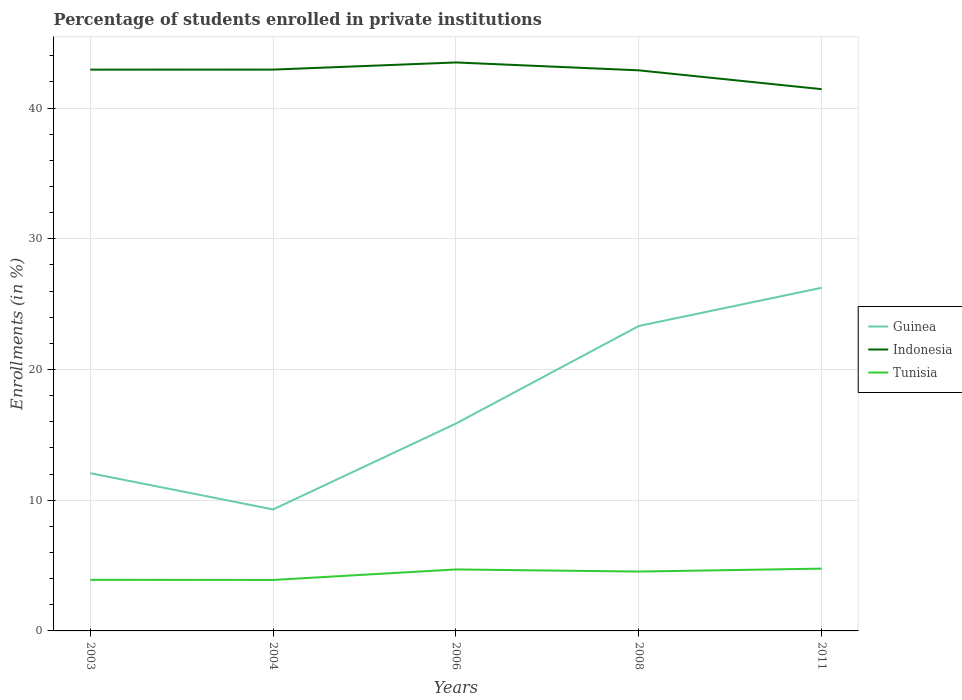Is the number of lines equal to the number of legend labels?
Offer a very short reply. Yes. Across all years, what is the maximum percentage of trained teachers in Guinea?
Offer a very short reply. 9.29. In which year was the percentage of trained teachers in Indonesia maximum?
Keep it short and to the point. 2011. What is the total percentage of trained teachers in Tunisia in the graph?
Ensure brevity in your answer.  -0.79. What is the difference between the highest and the second highest percentage of trained teachers in Indonesia?
Offer a very short reply. 2.04. How many years are there in the graph?
Your answer should be compact. 5. What is the title of the graph?
Offer a very short reply. Percentage of students enrolled in private institutions. Does "Equatorial Guinea" appear as one of the legend labels in the graph?
Give a very brief answer. No. What is the label or title of the X-axis?
Keep it short and to the point. Years. What is the label or title of the Y-axis?
Give a very brief answer. Enrollments (in %). What is the Enrollments (in %) in Guinea in 2003?
Give a very brief answer. 12.07. What is the Enrollments (in %) in Indonesia in 2003?
Your answer should be very brief. 42.94. What is the Enrollments (in %) in Tunisia in 2003?
Offer a terse response. 3.91. What is the Enrollments (in %) of Guinea in 2004?
Give a very brief answer. 9.29. What is the Enrollments (in %) in Indonesia in 2004?
Provide a short and direct response. 42.94. What is the Enrollments (in %) in Tunisia in 2004?
Provide a succinct answer. 3.9. What is the Enrollments (in %) in Guinea in 2006?
Provide a short and direct response. 15.86. What is the Enrollments (in %) of Indonesia in 2006?
Your answer should be very brief. 43.49. What is the Enrollments (in %) of Tunisia in 2006?
Offer a terse response. 4.7. What is the Enrollments (in %) in Guinea in 2008?
Your response must be concise. 23.33. What is the Enrollments (in %) of Indonesia in 2008?
Ensure brevity in your answer.  42.89. What is the Enrollments (in %) in Tunisia in 2008?
Ensure brevity in your answer.  4.54. What is the Enrollments (in %) in Guinea in 2011?
Keep it short and to the point. 26.25. What is the Enrollments (in %) of Indonesia in 2011?
Offer a terse response. 41.45. What is the Enrollments (in %) in Tunisia in 2011?
Provide a succinct answer. 4.77. Across all years, what is the maximum Enrollments (in %) in Guinea?
Your answer should be very brief. 26.25. Across all years, what is the maximum Enrollments (in %) in Indonesia?
Ensure brevity in your answer.  43.49. Across all years, what is the maximum Enrollments (in %) in Tunisia?
Your response must be concise. 4.77. Across all years, what is the minimum Enrollments (in %) in Guinea?
Offer a very short reply. 9.29. Across all years, what is the minimum Enrollments (in %) of Indonesia?
Offer a terse response. 41.45. Across all years, what is the minimum Enrollments (in %) in Tunisia?
Provide a succinct answer. 3.9. What is the total Enrollments (in %) of Guinea in the graph?
Give a very brief answer. 86.8. What is the total Enrollments (in %) of Indonesia in the graph?
Ensure brevity in your answer.  213.7. What is the total Enrollments (in %) in Tunisia in the graph?
Provide a succinct answer. 21.82. What is the difference between the Enrollments (in %) in Guinea in 2003 and that in 2004?
Offer a very short reply. 2.77. What is the difference between the Enrollments (in %) in Indonesia in 2003 and that in 2004?
Offer a very short reply. -0. What is the difference between the Enrollments (in %) in Tunisia in 2003 and that in 2004?
Give a very brief answer. 0.01. What is the difference between the Enrollments (in %) of Guinea in 2003 and that in 2006?
Provide a short and direct response. -3.8. What is the difference between the Enrollments (in %) of Indonesia in 2003 and that in 2006?
Ensure brevity in your answer.  -0.55. What is the difference between the Enrollments (in %) of Tunisia in 2003 and that in 2006?
Ensure brevity in your answer.  -0.79. What is the difference between the Enrollments (in %) in Guinea in 2003 and that in 2008?
Your answer should be compact. -11.26. What is the difference between the Enrollments (in %) in Indonesia in 2003 and that in 2008?
Your response must be concise. 0.05. What is the difference between the Enrollments (in %) in Tunisia in 2003 and that in 2008?
Your answer should be compact. -0.63. What is the difference between the Enrollments (in %) in Guinea in 2003 and that in 2011?
Ensure brevity in your answer.  -14.18. What is the difference between the Enrollments (in %) in Indonesia in 2003 and that in 2011?
Give a very brief answer. 1.49. What is the difference between the Enrollments (in %) of Tunisia in 2003 and that in 2011?
Your answer should be compact. -0.86. What is the difference between the Enrollments (in %) of Guinea in 2004 and that in 2006?
Offer a terse response. -6.57. What is the difference between the Enrollments (in %) in Indonesia in 2004 and that in 2006?
Offer a very short reply. -0.55. What is the difference between the Enrollments (in %) of Tunisia in 2004 and that in 2006?
Ensure brevity in your answer.  -0.81. What is the difference between the Enrollments (in %) of Guinea in 2004 and that in 2008?
Provide a succinct answer. -14.03. What is the difference between the Enrollments (in %) of Indonesia in 2004 and that in 2008?
Make the answer very short. 0.06. What is the difference between the Enrollments (in %) in Tunisia in 2004 and that in 2008?
Make the answer very short. -0.64. What is the difference between the Enrollments (in %) in Guinea in 2004 and that in 2011?
Offer a terse response. -16.96. What is the difference between the Enrollments (in %) of Indonesia in 2004 and that in 2011?
Your answer should be very brief. 1.5. What is the difference between the Enrollments (in %) in Tunisia in 2004 and that in 2011?
Your answer should be very brief. -0.87. What is the difference between the Enrollments (in %) of Guinea in 2006 and that in 2008?
Provide a succinct answer. -7.46. What is the difference between the Enrollments (in %) in Indonesia in 2006 and that in 2008?
Ensure brevity in your answer.  0.6. What is the difference between the Enrollments (in %) of Tunisia in 2006 and that in 2008?
Offer a terse response. 0.16. What is the difference between the Enrollments (in %) of Guinea in 2006 and that in 2011?
Ensure brevity in your answer.  -10.39. What is the difference between the Enrollments (in %) in Indonesia in 2006 and that in 2011?
Keep it short and to the point. 2.04. What is the difference between the Enrollments (in %) of Tunisia in 2006 and that in 2011?
Give a very brief answer. -0.06. What is the difference between the Enrollments (in %) in Guinea in 2008 and that in 2011?
Offer a terse response. -2.92. What is the difference between the Enrollments (in %) in Indonesia in 2008 and that in 2011?
Provide a succinct answer. 1.44. What is the difference between the Enrollments (in %) of Tunisia in 2008 and that in 2011?
Provide a short and direct response. -0.23. What is the difference between the Enrollments (in %) in Guinea in 2003 and the Enrollments (in %) in Indonesia in 2004?
Ensure brevity in your answer.  -30.88. What is the difference between the Enrollments (in %) of Guinea in 2003 and the Enrollments (in %) of Tunisia in 2004?
Offer a very short reply. 8.17. What is the difference between the Enrollments (in %) of Indonesia in 2003 and the Enrollments (in %) of Tunisia in 2004?
Give a very brief answer. 39.04. What is the difference between the Enrollments (in %) of Guinea in 2003 and the Enrollments (in %) of Indonesia in 2006?
Provide a short and direct response. -31.42. What is the difference between the Enrollments (in %) in Guinea in 2003 and the Enrollments (in %) in Tunisia in 2006?
Offer a very short reply. 7.36. What is the difference between the Enrollments (in %) of Indonesia in 2003 and the Enrollments (in %) of Tunisia in 2006?
Provide a short and direct response. 38.23. What is the difference between the Enrollments (in %) in Guinea in 2003 and the Enrollments (in %) in Indonesia in 2008?
Keep it short and to the point. -30.82. What is the difference between the Enrollments (in %) in Guinea in 2003 and the Enrollments (in %) in Tunisia in 2008?
Your answer should be compact. 7.53. What is the difference between the Enrollments (in %) in Indonesia in 2003 and the Enrollments (in %) in Tunisia in 2008?
Offer a very short reply. 38.4. What is the difference between the Enrollments (in %) of Guinea in 2003 and the Enrollments (in %) of Indonesia in 2011?
Offer a very short reply. -29.38. What is the difference between the Enrollments (in %) in Guinea in 2003 and the Enrollments (in %) in Tunisia in 2011?
Your response must be concise. 7.3. What is the difference between the Enrollments (in %) of Indonesia in 2003 and the Enrollments (in %) of Tunisia in 2011?
Provide a short and direct response. 38.17. What is the difference between the Enrollments (in %) in Guinea in 2004 and the Enrollments (in %) in Indonesia in 2006?
Ensure brevity in your answer.  -34.2. What is the difference between the Enrollments (in %) of Guinea in 2004 and the Enrollments (in %) of Tunisia in 2006?
Provide a succinct answer. 4.59. What is the difference between the Enrollments (in %) of Indonesia in 2004 and the Enrollments (in %) of Tunisia in 2006?
Keep it short and to the point. 38.24. What is the difference between the Enrollments (in %) of Guinea in 2004 and the Enrollments (in %) of Indonesia in 2008?
Offer a very short reply. -33.59. What is the difference between the Enrollments (in %) in Guinea in 2004 and the Enrollments (in %) in Tunisia in 2008?
Keep it short and to the point. 4.75. What is the difference between the Enrollments (in %) in Indonesia in 2004 and the Enrollments (in %) in Tunisia in 2008?
Your answer should be compact. 38.4. What is the difference between the Enrollments (in %) in Guinea in 2004 and the Enrollments (in %) in Indonesia in 2011?
Your answer should be very brief. -32.15. What is the difference between the Enrollments (in %) of Guinea in 2004 and the Enrollments (in %) of Tunisia in 2011?
Your answer should be compact. 4.53. What is the difference between the Enrollments (in %) of Indonesia in 2004 and the Enrollments (in %) of Tunisia in 2011?
Offer a terse response. 38.18. What is the difference between the Enrollments (in %) of Guinea in 2006 and the Enrollments (in %) of Indonesia in 2008?
Give a very brief answer. -27.02. What is the difference between the Enrollments (in %) in Guinea in 2006 and the Enrollments (in %) in Tunisia in 2008?
Offer a terse response. 11.32. What is the difference between the Enrollments (in %) in Indonesia in 2006 and the Enrollments (in %) in Tunisia in 2008?
Your response must be concise. 38.95. What is the difference between the Enrollments (in %) of Guinea in 2006 and the Enrollments (in %) of Indonesia in 2011?
Give a very brief answer. -25.58. What is the difference between the Enrollments (in %) of Guinea in 2006 and the Enrollments (in %) of Tunisia in 2011?
Give a very brief answer. 11.1. What is the difference between the Enrollments (in %) of Indonesia in 2006 and the Enrollments (in %) of Tunisia in 2011?
Offer a very short reply. 38.72. What is the difference between the Enrollments (in %) in Guinea in 2008 and the Enrollments (in %) in Indonesia in 2011?
Make the answer very short. -18.12. What is the difference between the Enrollments (in %) in Guinea in 2008 and the Enrollments (in %) in Tunisia in 2011?
Provide a succinct answer. 18.56. What is the difference between the Enrollments (in %) of Indonesia in 2008 and the Enrollments (in %) of Tunisia in 2011?
Provide a succinct answer. 38.12. What is the average Enrollments (in %) of Guinea per year?
Your answer should be compact. 17.36. What is the average Enrollments (in %) in Indonesia per year?
Make the answer very short. 42.74. What is the average Enrollments (in %) of Tunisia per year?
Give a very brief answer. 4.36. In the year 2003, what is the difference between the Enrollments (in %) in Guinea and Enrollments (in %) in Indonesia?
Make the answer very short. -30.87. In the year 2003, what is the difference between the Enrollments (in %) of Guinea and Enrollments (in %) of Tunisia?
Provide a short and direct response. 8.16. In the year 2003, what is the difference between the Enrollments (in %) in Indonesia and Enrollments (in %) in Tunisia?
Provide a succinct answer. 39.03. In the year 2004, what is the difference between the Enrollments (in %) in Guinea and Enrollments (in %) in Indonesia?
Your answer should be compact. -33.65. In the year 2004, what is the difference between the Enrollments (in %) in Guinea and Enrollments (in %) in Tunisia?
Your answer should be very brief. 5.39. In the year 2004, what is the difference between the Enrollments (in %) of Indonesia and Enrollments (in %) of Tunisia?
Make the answer very short. 39.04. In the year 2006, what is the difference between the Enrollments (in %) of Guinea and Enrollments (in %) of Indonesia?
Your answer should be compact. -27.62. In the year 2006, what is the difference between the Enrollments (in %) of Guinea and Enrollments (in %) of Tunisia?
Your response must be concise. 11.16. In the year 2006, what is the difference between the Enrollments (in %) of Indonesia and Enrollments (in %) of Tunisia?
Your response must be concise. 38.78. In the year 2008, what is the difference between the Enrollments (in %) of Guinea and Enrollments (in %) of Indonesia?
Your response must be concise. -19.56. In the year 2008, what is the difference between the Enrollments (in %) in Guinea and Enrollments (in %) in Tunisia?
Your answer should be compact. 18.79. In the year 2008, what is the difference between the Enrollments (in %) in Indonesia and Enrollments (in %) in Tunisia?
Offer a terse response. 38.34. In the year 2011, what is the difference between the Enrollments (in %) in Guinea and Enrollments (in %) in Indonesia?
Offer a terse response. -15.19. In the year 2011, what is the difference between the Enrollments (in %) in Guinea and Enrollments (in %) in Tunisia?
Provide a succinct answer. 21.48. In the year 2011, what is the difference between the Enrollments (in %) in Indonesia and Enrollments (in %) in Tunisia?
Offer a very short reply. 36.68. What is the ratio of the Enrollments (in %) of Guinea in 2003 to that in 2004?
Ensure brevity in your answer.  1.3. What is the ratio of the Enrollments (in %) in Guinea in 2003 to that in 2006?
Make the answer very short. 0.76. What is the ratio of the Enrollments (in %) in Indonesia in 2003 to that in 2006?
Your answer should be compact. 0.99. What is the ratio of the Enrollments (in %) in Tunisia in 2003 to that in 2006?
Make the answer very short. 0.83. What is the ratio of the Enrollments (in %) of Guinea in 2003 to that in 2008?
Your answer should be very brief. 0.52. What is the ratio of the Enrollments (in %) of Tunisia in 2003 to that in 2008?
Make the answer very short. 0.86. What is the ratio of the Enrollments (in %) of Guinea in 2003 to that in 2011?
Your response must be concise. 0.46. What is the ratio of the Enrollments (in %) in Indonesia in 2003 to that in 2011?
Offer a very short reply. 1.04. What is the ratio of the Enrollments (in %) in Tunisia in 2003 to that in 2011?
Make the answer very short. 0.82. What is the ratio of the Enrollments (in %) of Guinea in 2004 to that in 2006?
Make the answer very short. 0.59. What is the ratio of the Enrollments (in %) in Indonesia in 2004 to that in 2006?
Your response must be concise. 0.99. What is the ratio of the Enrollments (in %) in Tunisia in 2004 to that in 2006?
Your answer should be very brief. 0.83. What is the ratio of the Enrollments (in %) in Guinea in 2004 to that in 2008?
Make the answer very short. 0.4. What is the ratio of the Enrollments (in %) in Indonesia in 2004 to that in 2008?
Make the answer very short. 1. What is the ratio of the Enrollments (in %) of Tunisia in 2004 to that in 2008?
Your response must be concise. 0.86. What is the ratio of the Enrollments (in %) in Guinea in 2004 to that in 2011?
Give a very brief answer. 0.35. What is the ratio of the Enrollments (in %) in Indonesia in 2004 to that in 2011?
Ensure brevity in your answer.  1.04. What is the ratio of the Enrollments (in %) in Tunisia in 2004 to that in 2011?
Provide a succinct answer. 0.82. What is the ratio of the Enrollments (in %) of Guinea in 2006 to that in 2008?
Offer a terse response. 0.68. What is the ratio of the Enrollments (in %) of Indonesia in 2006 to that in 2008?
Your response must be concise. 1.01. What is the ratio of the Enrollments (in %) in Tunisia in 2006 to that in 2008?
Ensure brevity in your answer.  1.04. What is the ratio of the Enrollments (in %) of Guinea in 2006 to that in 2011?
Give a very brief answer. 0.6. What is the ratio of the Enrollments (in %) in Indonesia in 2006 to that in 2011?
Your response must be concise. 1.05. What is the ratio of the Enrollments (in %) in Tunisia in 2006 to that in 2011?
Provide a short and direct response. 0.99. What is the ratio of the Enrollments (in %) in Guinea in 2008 to that in 2011?
Ensure brevity in your answer.  0.89. What is the ratio of the Enrollments (in %) of Indonesia in 2008 to that in 2011?
Keep it short and to the point. 1.03. What is the ratio of the Enrollments (in %) of Tunisia in 2008 to that in 2011?
Offer a very short reply. 0.95. What is the difference between the highest and the second highest Enrollments (in %) of Guinea?
Keep it short and to the point. 2.92. What is the difference between the highest and the second highest Enrollments (in %) in Indonesia?
Your answer should be compact. 0.55. What is the difference between the highest and the second highest Enrollments (in %) of Tunisia?
Keep it short and to the point. 0.06. What is the difference between the highest and the lowest Enrollments (in %) in Guinea?
Provide a succinct answer. 16.96. What is the difference between the highest and the lowest Enrollments (in %) in Indonesia?
Offer a very short reply. 2.04. What is the difference between the highest and the lowest Enrollments (in %) of Tunisia?
Ensure brevity in your answer.  0.87. 